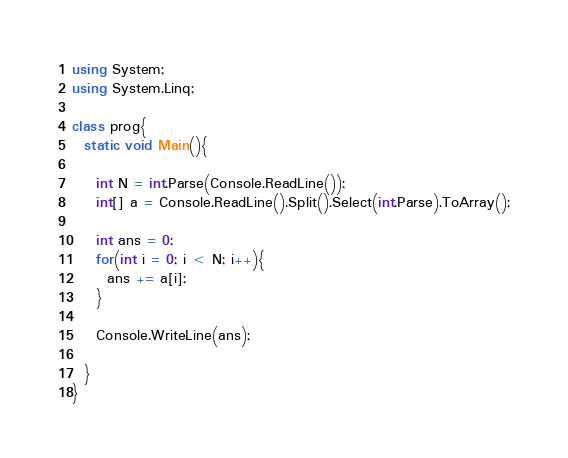<code> <loc_0><loc_0><loc_500><loc_500><_C#_>using System;
using System.Linq;

class prog{
  static void Main(){
    
    int N = int.Parse(Console.ReadLine());
    int[] a = Console.ReadLine().Split().Select(int.Parse).ToArray();
    
    int ans = 0;
    for(int i = 0; i < N; i++){
      ans += a[i];
    }
    
    Console.WriteLine(ans);
    
  }
}</code> 